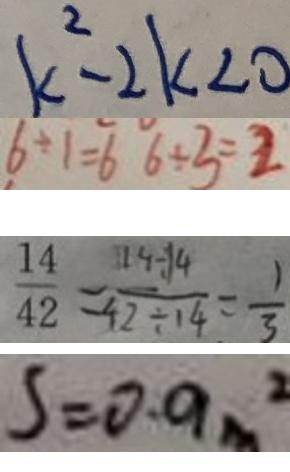Convert formula to latex. <formula><loc_0><loc_0><loc_500><loc_500>k ^ { 2 } - 2 k < 0 
 6 \div 1 = 6 6 \div 3 = 2 
 \frac { 1 4 } { 4 2 } = \frac { 1 4 \div 1 4 } { 4 2 \div 1 4 } = \frac { 1 } { 3 } 
 s = 0 . 9 m ^ { 2 }</formula> 